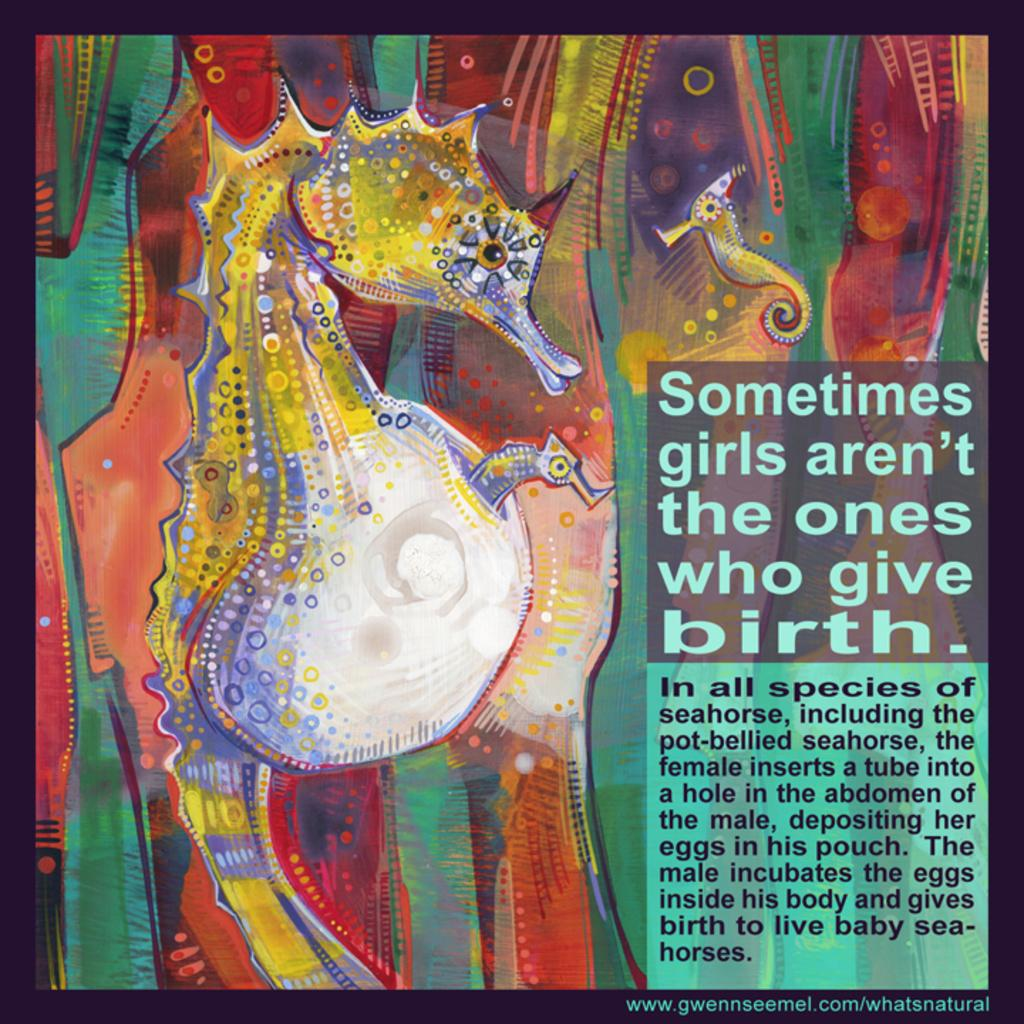What is the main subject of the image? There is an artwork in the image. What is depicted in the artwork? The artwork features a dragon seahorse on the left side. Is there any text present in the image? Yes, there is text on the right side of the artwork. How many cats are sitting on the root in the image? There are no cats or roots present in the image. 